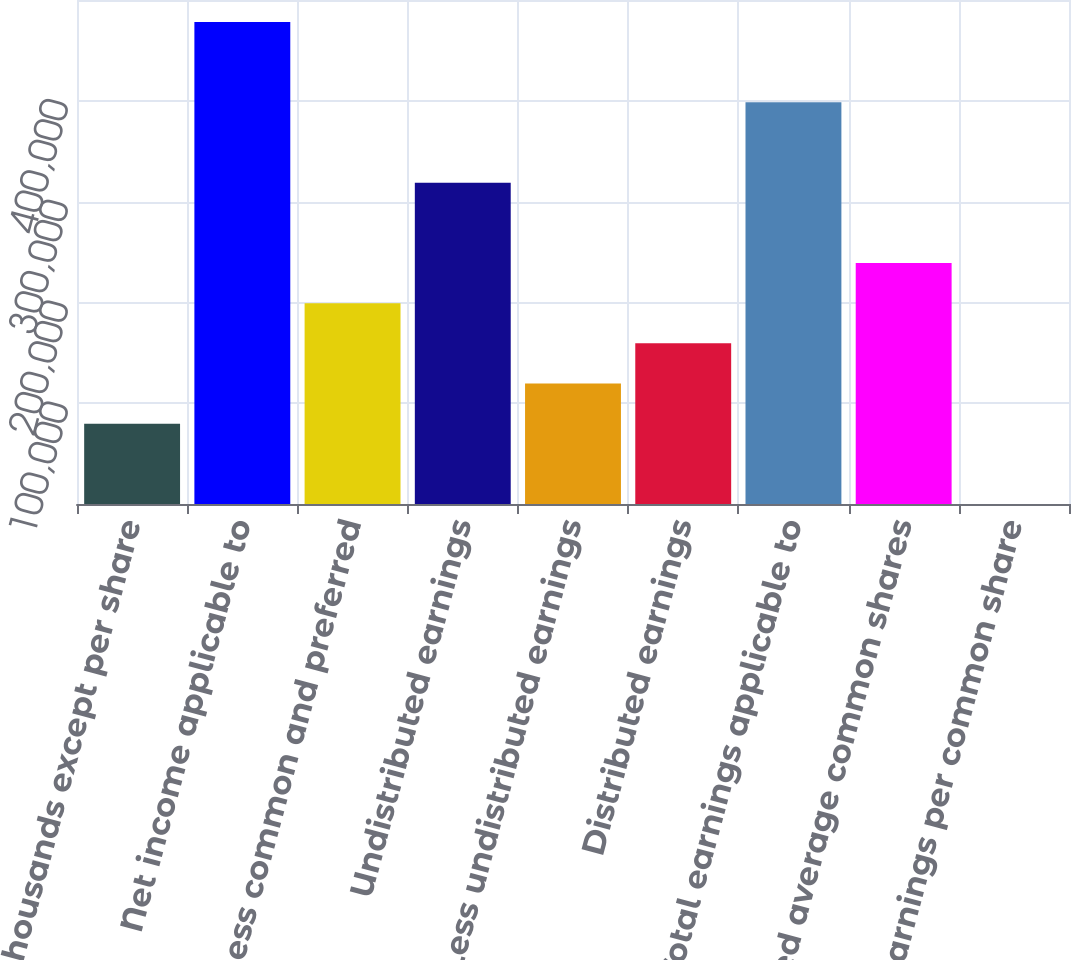Convert chart to OTSL. <chart><loc_0><loc_0><loc_500><loc_500><bar_chart><fcel>(In thousands except per share<fcel>Net income applicable to<fcel>Less common and preferred<fcel>Undistributed earnings<fcel>Less undistributed earnings<fcel>Distributed earnings<fcel>Total earnings applicable to<fcel>Weighted average common shares<fcel>Net earnings per common share<nl><fcel>79693.7<fcel>478154<fcel>199232<fcel>318770<fcel>119540<fcel>159386<fcel>398462<fcel>239078<fcel>1.68<nl></chart> 